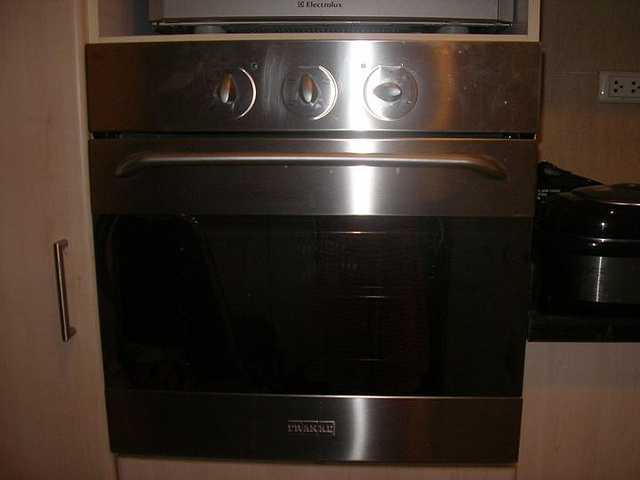Describe the objects in this image and their specific colors. I can see a oven in black, maroon, and gray tones in this image. 